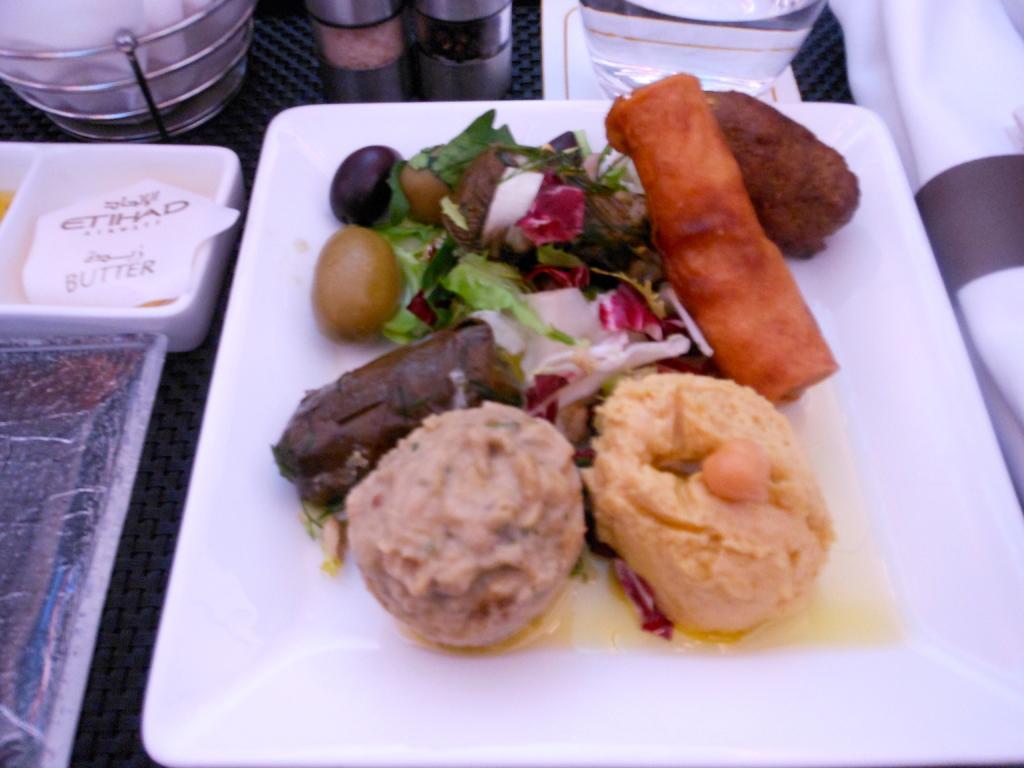In one or two sentences, can you explain what this image depicts? In this picture there is a plate in the center of the image, which contains food items in it and there is a glass at the top side of the image and there are salt and pepper shakers at the top side of the image, it seems to be there is a tissue holder in the top left side of the image. 